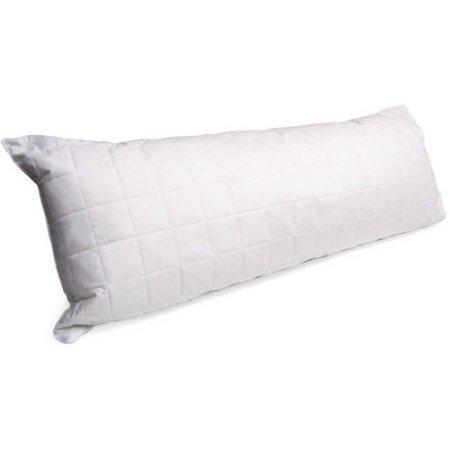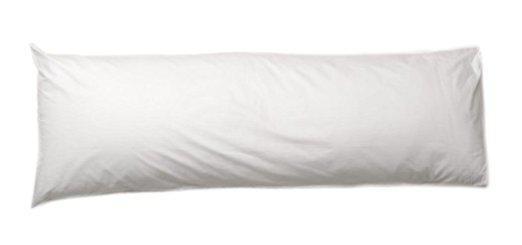The first image is the image on the left, the second image is the image on the right. Analyze the images presented: Is the assertion "The pillow on the right is white and displayed horizontally, and the pillow on the left is white and displayed at some angle instead of horizontally." valid? Answer yes or no. Yes. The first image is the image on the left, the second image is the image on the right. Given the left and right images, does the statement "The left and right image contains the same number of long white body pillows." hold true? Answer yes or no. Yes. 